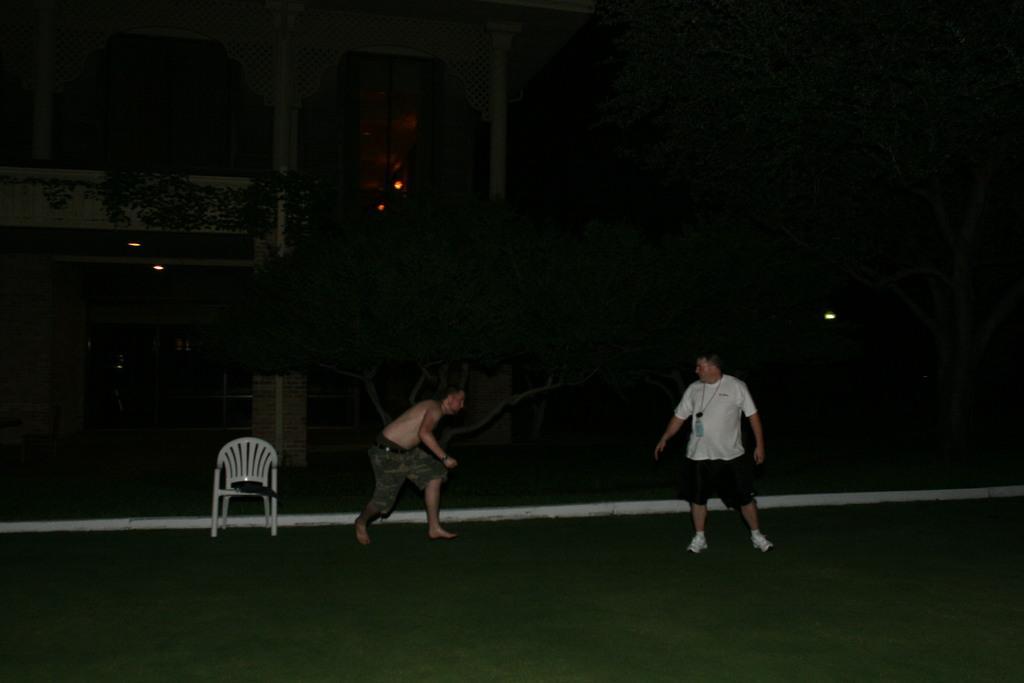How would you summarize this image in a sentence or two? In this image we can see there are people standing on the ground. And at the back there is a chair, on that chair it looks like an object. And there are trees, buildings and lights. 